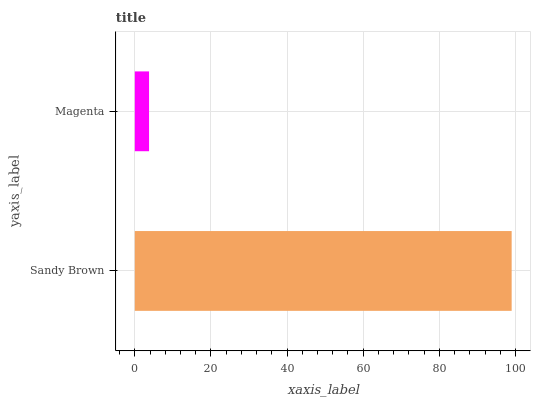Is Magenta the minimum?
Answer yes or no. Yes. Is Sandy Brown the maximum?
Answer yes or no. Yes. Is Magenta the maximum?
Answer yes or no. No. Is Sandy Brown greater than Magenta?
Answer yes or no. Yes. Is Magenta less than Sandy Brown?
Answer yes or no. Yes. Is Magenta greater than Sandy Brown?
Answer yes or no. No. Is Sandy Brown less than Magenta?
Answer yes or no. No. Is Sandy Brown the high median?
Answer yes or no. Yes. Is Magenta the low median?
Answer yes or no. Yes. Is Magenta the high median?
Answer yes or no. No. Is Sandy Brown the low median?
Answer yes or no. No. 